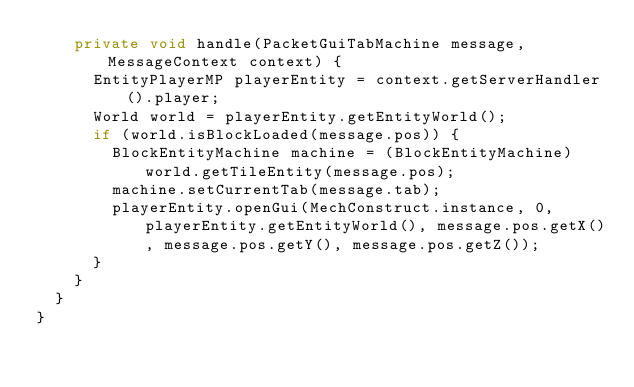Convert code to text. <code><loc_0><loc_0><loc_500><loc_500><_Java_>		private void handle(PacketGuiTabMachine message, MessageContext context) {
			EntityPlayerMP playerEntity = context.getServerHandler().player;
			World world = playerEntity.getEntityWorld();
			if (world.isBlockLoaded(message.pos)) {
				BlockEntityMachine machine = (BlockEntityMachine) world.getTileEntity(message.pos);
				machine.setCurrentTab(message.tab);
				playerEntity.openGui(MechConstruct.instance, 0, playerEntity.getEntityWorld(), message.pos.getX(), message.pos.getY(), message.pos.getZ());
			}
		}
	}
}
</code> 